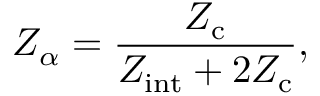Convert formula to latex. <formula><loc_0><loc_0><loc_500><loc_500>Z _ { \alpha } = \frac { Z _ { c } } { Z _ { i n t } + 2 Z _ { c } } ,</formula> 